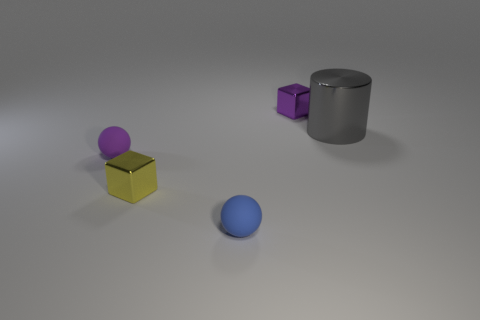What shape is the small purple thing that is on the left side of the rubber object in front of the cube that is in front of the gray shiny object?
Your answer should be very brief. Sphere. What number of blocks are either large metallic objects or tiny objects?
Keep it short and to the point. 2. Is there a tiny blue sphere that is left of the cube behind the tiny yellow object?
Offer a very short reply. Yes. Is there any other thing that has the same material as the small blue sphere?
Offer a very short reply. Yes. Do the small yellow thing and the purple metal object on the left side of the gray thing have the same shape?
Your response must be concise. Yes. How many other things are there of the same size as the blue thing?
Offer a very short reply. 3. What number of purple things are tiny metallic blocks or shiny things?
Offer a terse response. 1. How many small things are both behind the blue rubber ball and left of the tiny purple metal block?
Give a very brief answer. 2. What material is the cube that is right of the cube in front of the tiny block that is behind the tiny yellow metallic cube?
Offer a terse response. Metal. How many yellow objects have the same material as the big gray thing?
Provide a short and direct response. 1. 